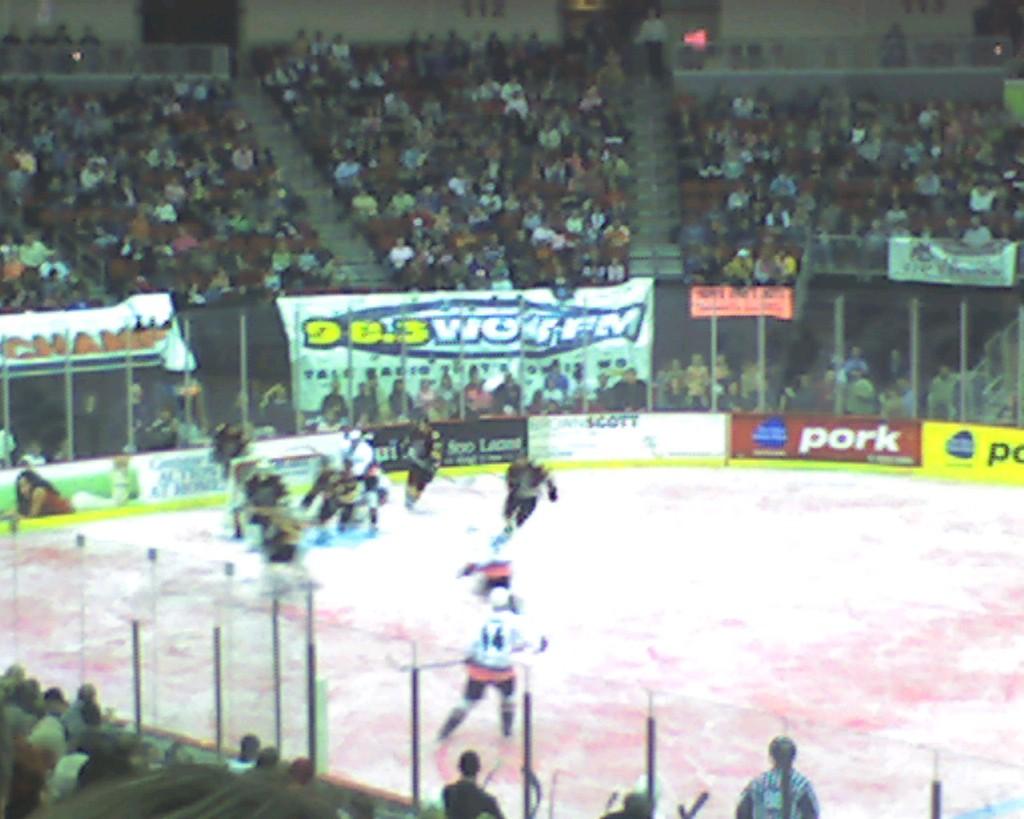What radio station is it?
Your answer should be compact. 98.3. 